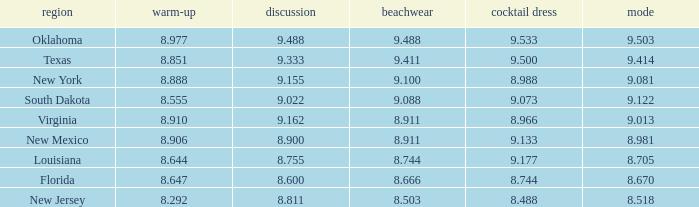 what's the preliminaries where state is south dakota 8.555. Could you help me parse every detail presented in this table? {'header': ['region', 'warm-up', 'discussion', 'beachwear', 'cocktail dress', 'mode'], 'rows': [['Oklahoma', '8.977', '9.488', '9.488', '9.533', '9.503'], ['Texas', '8.851', '9.333', '9.411', '9.500', '9.414'], ['New York', '8.888', '9.155', '9.100', '8.988', '9.081'], ['South Dakota', '8.555', '9.022', '9.088', '9.073', '9.122'], ['Virginia', '8.910', '9.162', '8.911', '8.966', '9.013'], ['New Mexico', '8.906', '8.900', '8.911', '9.133', '8.981'], ['Louisiana', '8.644', '8.755', '8.744', '9.177', '8.705'], ['Florida', '8.647', '8.600', '8.666', '8.744', '8.670'], ['New Jersey', '8.292', '8.811', '8.503', '8.488', '8.518']]} 